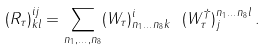<formula> <loc_0><loc_0><loc_500><loc_500>( R _ { \tau } ) _ { k l } ^ { i j } = \sum _ { n _ { 1 } , \dots , n _ { 8 } } ( W _ { \tau } ) ^ { i } _ { n _ { 1 } \dots n _ { 8 } k } \ ( W ^ { \dag } _ { \tau } ) _ { j } ^ { n _ { 1 } \dots n _ { 8 } l } \, .</formula> 